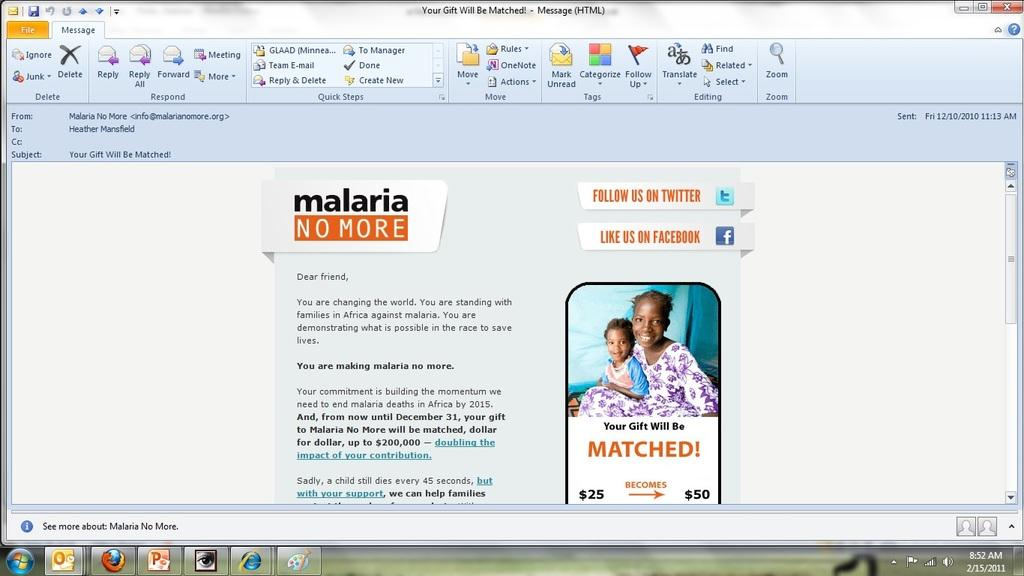<image>
Describe the image concisely. A windows screenshot from February 15th 2011 showing an email from malaria no more. 